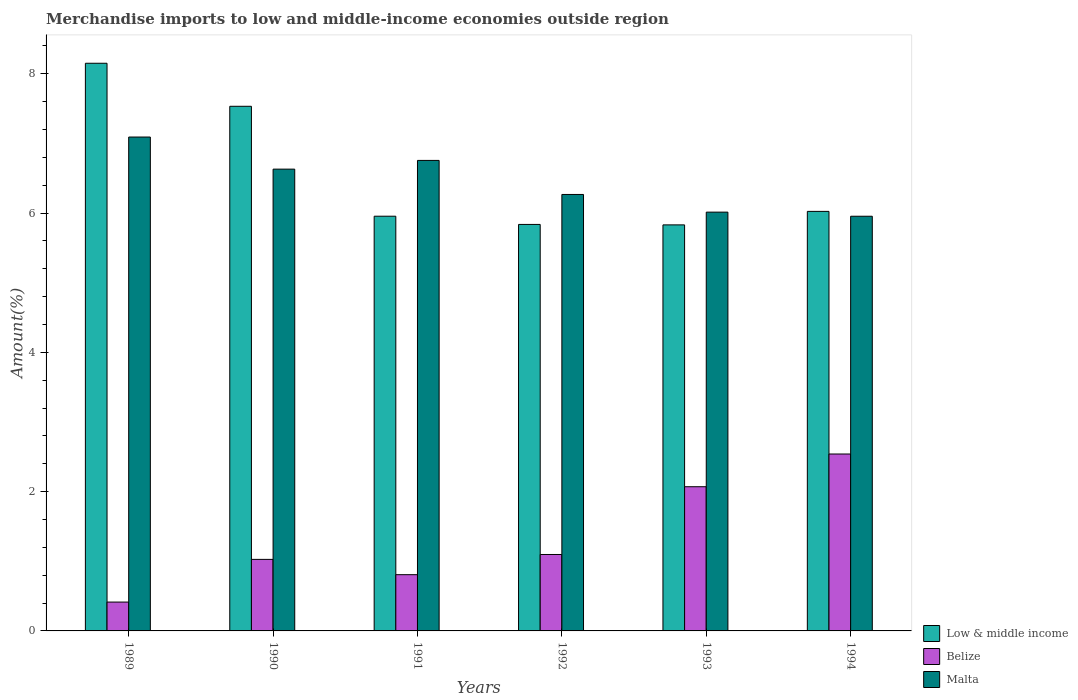How many different coloured bars are there?
Offer a terse response. 3. Are the number of bars per tick equal to the number of legend labels?
Make the answer very short. Yes. What is the label of the 3rd group of bars from the left?
Give a very brief answer. 1991. In how many cases, is the number of bars for a given year not equal to the number of legend labels?
Offer a very short reply. 0. What is the percentage of amount earned from merchandise imports in Belize in 1991?
Your answer should be very brief. 0.81. Across all years, what is the maximum percentage of amount earned from merchandise imports in Malta?
Make the answer very short. 7.09. Across all years, what is the minimum percentage of amount earned from merchandise imports in Malta?
Ensure brevity in your answer.  5.95. In which year was the percentage of amount earned from merchandise imports in Belize maximum?
Give a very brief answer. 1994. What is the total percentage of amount earned from merchandise imports in Belize in the graph?
Your answer should be very brief. 7.96. What is the difference between the percentage of amount earned from merchandise imports in Belize in 1990 and that in 1991?
Offer a terse response. 0.22. What is the difference between the percentage of amount earned from merchandise imports in Low & middle income in 1993 and the percentage of amount earned from merchandise imports in Malta in 1991?
Give a very brief answer. -0.93. What is the average percentage of amount earned from merchandise imports in Low & middle income per year?
Offer a terse response. 6.55. In the year 1994, what is the difference between the percentage of amount earned from merchandise imports in Low & middle income and percentage of amount earned from merchandise imports in Malta?
Offer a terse response. 0.07. In how many years, is the percentage of amount earned from merchandise imports in Belize greater than 4 %?
Provide a succinct answer. 0. What is the ratio of the percentage of amount earned from merchandise imports in Malta in 1989 to that in 1991?
Make the answer very short. 1.05. What is the difference between the highest and the second highest percentage of amount earned from merchandise imports in Low & middle income?
Keep it short and to the point. 0.62. What is the difference between the highest and the lowest percentage of amount earned from merchandise imports in Low & middle income?
Your answer should be compact. 2.32. In how many years, is the percentage of amount earned from merchandise imports in Belize greater than the average percentage of amount earned from merchandise imports in Belize taken over all years?
Ensure brevity in your answer.  2. What does the 2nd bar from the left in 1989 represents?
Your answer should be very brief. Belize. Is it the case that in every year, the sum of the percentage of amount earned from merchandise imports in Low & middle income and percentage of amount earned from merchandise imports in Malta is greater than the percentage of amount earned from merchandise imports in Belize?
Provide a succinct answer. Yes. Are all the bars in the graph horizontal?
Your answer should be compact. No. What is the difference between two consecutive major ticks on the Y-axis?
Provide a short and direct response. 2. Does the graph contain grids?
Ensure brevity in your answer.  No. Where does the legend appear in the graph?
Give a very brief answer. Bottom right. What is the title of the graph?
Your answer should be compact. Merchandise imports to low and middle-income economies outside region. What is the label or title of the X-axis?
Make the answer very short. Years. What is the label or title of the Y-axis?
Your response must be concise. Amount(%). What is the Amount(%) of Low & middle income in 1989?
Provide a succinct answer. 8.15. What is the Amount(%) in Belize in 1989?
Provide a short and direct response. 0.41. What is the Amount(%) of Malta in 1989?
Ensure brevity in your answer.  7.09. What is the Amount(%) in Low & middle income in 1990?
Provide a succinct answer. 7.53. What is the Amount(%) in Belize in 1990?
Give a very brief answer. 1.03. What is the Amount(%) of Malta in 1990?
Provide a short and direct response. 6.63. What is the Amount(%) in Low & middle income in 1991?
Keep it short and to the point. 5.95. What is the Amount(%) in Belize in 1991?
Make the answer very short. 0.81. What is the Amount(%) in Malta in 1991?
Provide a succinct answer. 6.76. What is the Amount(%) in Low & middle income in 1992?
Offer a terse response. 5.84. What is the Amount(%) in Belize in 1992?
Your answer should be very brief. 1.1. What is the Amount(%) of Malta in 1992?
Give a very brief answer. 6.27. What is the Amount(%) in Low & middle income in 1993?
Offer a terse response. 5.83. What is the Amount(%) in Belize in 1993?
Provide a short and direct response. 2.07. What is the Amount(%) of Malta in 1993?
Your response must be concise. 6.01. What is the Amount(%) in Low & middle income in 1994?
Keep it short and to the point. 6.02. What is the Amount(%) in Belize in 1994?
Provide a succinct answer. 2.54. What is the Amount(%) in Malta in 1994?
Your response must be concise. 5.95. Across all years, what is the maximum Amount(%) in Low & middle income?
Your answer should be very brief. 8.15. Across all years, what is the maximum Amount(%) in Belize?
Provide a short and direct response. 2.54. Across all years, what is the maximum Amount(%) of Malta?
Your response must be concise. 7.09. Across all years, what is the minimum Amount(%) in Low & middle income?
Offer a very short reply. 5.83. Across all years, what is the minimum Amount(%) of Belize?
Offer a very short reply. 0.41. Across all years, what is the minimum Amount(%) in Malta?
Make the answer very short. 5.95. What is the total Amount(%) in Low & middle income in the graph?
Provide a succinct answer. 39.33. What is the total Amount(%) in Belize in the graph?
Offer a very short reply. 7.96. What is the total Amount(%) of Malta in the graph?
Provide a short and direct response. 38.71. What is the difference between the Amount(%) in Low & middle income in 1989 and that in 1990?
Offer a terse response. 0.62. What is the difference between the Amount(%) of Belize in 1989 and that in 1990?
Your answer should be compact. -0.61. What is the difference between the Amount(%) in Malta in 1989 and that in 1990?
Offer a terse response. 0.46. What is the difference between the Amount(%) in Low & middle income in 1989 and that in 1991?
Provide a short and direct response. 2.2. What is the difference between the Amount(%) in Belize in 1989 and that in 1991?
Provide a succinct answer. -0.39. What is the difference between the Amount(%) of Malta in 1989 and that in 1991?
Keep it short and to the point. 0.34. What is the difference between the Amount(%) in Low & middle income in 1989 and that in 1992?
Ensure brevity in your answer.  2.31. What is the difference between the Amount(%) of Belize in 1989 and that in 1992?
Offer a very short reply. -0.68. What is the difference between the Amount(%) in Malta in 1989 and that in 1992?
Your answer should be very brief. 0.82. What is the difference between the Amount(%) of Low & middle income in 1989 and that in 1993?
Give a very brief answer. 2.32. What is the difference between the Amount(%) in Belize in 1989 and that in 1993?
Offer a terse response. -1.66. What is the difference between the Amount(%) in Malta in 1989 and that in 1993?
Your response must be concise. 1.08. What is the difference between the Amount(%) of Low & middle income in 1989 and that in 1994?
Make the answer very short. 2.13. What is the difference between the Amount(%) in Belize in 1989 and that in 1994?
Provide a succinct answer. -2.13. What is the difference between the Amount(%) in Malta in 1989 and that in 1994?
Your response must be concise. 1.14. What is the difference between the Amount(%) in Low & middle income in 1990 and that in 1991?
Your answer should be compact. 1.58. What is the difference between the Amount(%) in Belize in 1990 and that in 1991?
Give a very brief answer. 0.22. What is the difference between the Amount(%) in Malta in 1990 and that in 1991?
Keep it short and to the point. -0.12. What is the difference between the Amount(%) of Low & middle income in 1990 and that in 1992?
Your response must be concise. 1.7. What is the difference between the Amount(%) of Belize in 1990 and that in 1992?
Give a very brief answer. -0.07. What is the difference between the Amount(%) in Malta in 1990 and that in 1992?
Keep it short and to the point. 0.36. What is the difference between the Amount(%) in Low & middle income in 1990 and that in 1993?
Offer a terse response. 1.7. What is the difference between the Amount(%) in Belize in 1990 and that in 1993?
Keep it short and to the point. -1.04. What is the difference between the Amount(%) of Malta in 1990 and that in 1993?
Ensure brevity in your answer.  0.62. What is the difference between the Amount(%) of Low & middle income in 1990 and that in 1994?
Give a very brief answer. 1.51. What is the difference between the Amount(%) in Belize in 1990 and that in 1994?
Keep it short and to the point. -1.51. What is the difference between the Amount(%) in Malta in 1990 and that in 1994?
Your response must be concise. 0.68. What is the difference between the Amount(%) of Low & middle income in 1991 and that in 1992?
Keep it short and to the point. 0.12. What is the difference between the Amount(%) in Belize in 1991 and that in 1992?
Ensure brevity in your answer.  -0.29. What is the difference between the Amount(%) of Malta in 1991 and that in 1992?
Make the answer very short. 0.49. What is the difference between the Amount(%) in Low & middle income in 1991 and that in 1993?
Your answer should be compact. 0.12. What is the difference between the Amount(%) in Belize in 1991 and that in 1993?
Make the answer very short. -1.26. What is the difference between the Amount(%) of Malta in 1991 and that in 1993?
Provide a succinct answer. 0.74. What is the difference between the Amount(%) of Low & middle income in 1991 and that in 1994?
Offer a terse response. -0.07. What is the difference between the Amount(%) in Belize in 1991 and that in 1994?
Your response must be concise. -1.73. What is the difference between the Amount(%) of Malta in 1991 and that in 1994?
Offer a terse response. 0.8. What is the difference between the Amount(%) of Low & middle income in 1992 and that in 1993?
Your response must be concise. 0.01. What is the difference between the Amount(%) in Belize in 1992 and that in 1993?
Make the answer very short. -0.97. What is the difference between the Amount(%) of Malta in 1992 and that in 1993?
Your response must be concise. 0.25. What is the difference between the Amount(%) in Low & middle income in 1992 and that in 1994?
Provide a short and direct response. -0.19. What is the difference between the Amount(%) in Belize in 1992 and that in 1994?
Keep it short and to the point. -1.44. What is the difference between the Amount(%) of Malta in 1992 and that in 1994?
Provide a short and direct response. 0.31. What is the difference between the Amount(%) of Low & middle income in 1993 and that in 1994?
Your answer should be compact. -0.19. What is the difference between the Amount(%) in Belize in 1993 and that in 1994?
Provide a short and direct response. -0.47. What is the difference between the Amount(%) in Malta in 1993 and that in 1994?
Offer a terse response. 0.06. What is the difference between the Amount(%) of Low & middle income in 1989 and the Amount(%) of Belize in 1990?
Keep it short and to the point. 7.12. What is the difference between the Amount(%) of Low & middle income in 1989 and the Amount(%) of Malta in 1990?
Offer a very short reply. 1.52. What is the difference between the Amount(%) of Belize in 1989 and the Amount(%) of Malta in 1990?
Your answer should be very brief. -6.22. What is the difference between the Amount(%) of Low & middle income in 1989 and the Amount(%) of Belize in 1991?
Offer a very short reply. 7.34. What is the difference between the Amount(%) in Low & middle income in 1989 and the Amount(%) in Malta in 1991?
Provide a short and direct response. 1.39. What is the difference between the Amount(%) in Belize in 1989 and the Amount(%) in Malta in 1991?
Give a very brief answer. -6.34. What is the difference between the Amount(%) in Low & middle income in 1989 and the Amount(%) in Belize in 1992?
Provide a short and direct response. 7.05. What is the difference between the Amount(%) in Low & middle income in 1989 and the Amount(%) in Malta in 1992?
Your response must be concise. 1.88. What is the difference between the Amount(%) of Belize in 1989 and the Amount(%) of Malta in 1992?
Your answer should be very brief. -5.85. What is the difference between the Amount(%) of Low & middle income in 1989 and the Amount(%) of Belize in 1993?
Offer a very short reply. 6.08. What is the difference between the Amount(%) in Low & middle income in 1989 and the Amount(%) in Malta in 1993?
Give a very brief answer. 2.14. What is the difference between the Amount(%) of Belize in 1989 and the Amount(%) of Malta in 1993?
Keep it short and to the point. -5.6. What is the difference between the Amount(%) of Low & middle income in 1989 and the Amount(%) of Belize in 1994?
Give a very brief answer. 5.61. What is the difference between the Amount(%) in Low & middle income in 1989 and the Amount(%) in Malta in 1994?
Provide a short and direct response. 2.2. What is the difference between the Amount(%) in Belize in 1989 and the Amount(%) in Malta in 1994?
Offer a terse response. -5.54. What is the difference between the Amount(%) in Low & middle income in 1990 and the Amount(%) in Belize in 1991?
Your response must be concise. 6.72. What is the difference between the Amount(%) of Low & middle income in 1990 and the Amount(%) of Malta in 1991?
Make the answer very short. 0.78. What is the difference between the Amount(%) in Belize in 1990 and the Amount(%) in Malta in 1991?
Your answer should be very brief. -5.73. What is the difference between the Amount(%) of Low & middle income in 1990 and the Amount(%) of Belize in 1992?
Offer a very short reply. 6.43. What is the difference between the Amount(%) in Low & middle income in 1990 and the Amount(%) in Malta in 1992?
Your answer should be compact. 1.27. What is the difference between the Amount(%) in Belize in 1990 and the Amount(%) in Malta in 1992?
Ensure brevity in your answer.  -5.24. What is the difference between the Amount(%) in Low & middle income in 1990 and the Amount(%) in Belize in 1993?
Offer a very short reply. 5.46. What is the difference between the Amount(%) of Low & middle income in 1990 and the Amount(%) of Malta in 1993?
Give a very brief answer. 1.52. What is the difference between the Amount(%) in Belize in 1990 and the Amount(%) in Malta in 1993?
Provide a succinct answer. -4.99. What is the difference between the Amount(%) in Low & middle income in 1990 and the Amount(%) in Belize in 1994?
Provide a succinct answer. 4.99. What is the difference between the Amount(%) in Low & middle income in 1990 and the Amount(%) in Malta in 1994?
Your answer should be compact. 1.58. What is the difference between the Amount(%) of Belize in 1990 and the Amount(%) of Malta in 1994?
Provide a succinct answer. -4.93. What is the difference between the Amount(%) in Low & middle income in 1991 and the Amount(%) in Belize in 1992?
Ensure brevity in your answer.  4.86. What is the difference between the Amount(%) in Low & middle income in 1991 and the Amount(%) in Malta in 1992?
Provide a succinct answer. -0.31. What is the difference between the Amount(%) of Belize in 1991 and the Amount(%) of Malta in 1992?
Your response must be concise. -5.46. What is the difference between the Amount(%) of Low & middle income in 1991 and the Amount(%) of Belize in 1993?
Ensure brevity in your answer.  3.88. What is the difference between the Amount(%) in Low & middle income in 1991 and the Amount(%) in Malta in 1993?
Give a very brief answer. -0.06. What is the difference between the Amount(%) of Belize in 1991 and the Amount(%) of Malta in 1993?
Offer a very short reply. -5.21. What is the difference between the Amount(%) in Low & middle income in 1991 and the Amount(%) in Belize in 1994?
Your answer should be compact. 3.41. What is the difference between the Amount(%) of Low & middle income in 1991 and the Amount(%) of Malta in 1994?
Offer a terse response. 0. What is the difference between the Amount(%) of Belize in 1991 and the Amount(%) of Malta in 1994?
Offer a terse response. -5.15. What is the difference between the Amount(%) in Low & middle income in 1992 and the Amount(%) in Belize in 1993?
Make the answer very short. 3.77. What is the difference between the Amount(%) of Low & middle income in 1992 and the Amount(%) of Malta in 1993?
Provide a short and direct response. -0.18. What is the difference between the Amount(%) in Belize in 1992 and the Amount(%) in Malta in 1993?
Ensure brevity in your answer.  -4.92. What is the difference between the Amount(%) in Low & middle income in 1992 and the Amount(%) in Belize in 1994?
Offer a terse response. 3.3. What is the difference between the Amount(%) in Low & middle income in 1992 and the Amount(%) in Malta in 1994?
Offer a very short reply. -0.12. What is the difference between the Amount(%) in Belize in 1992 and the Amount(%) in Malta in 1994?
Your response must be concise. -4.86. What is the difference between the Amount(%) in Low & middle income in 1993 and the Amount(%) in Belize in 1994?
Offer a very short reply. 3.29. What is the difference between the Amount(%) in Low & middle income in 1993 and the Amount(%) in Malta in 1994?
Offer a terse response. -0.12. What is the difference between the Amount(%) in Belize in 1993 and the Amount(%) in Malta in 1994?
Make the answer very short. -3.88. What is the average Amount(%) of Low & middle income per year?
Provide a succinct answer. 6.55. What is the average Amount(%) in Belize per year?
Your answer should be very brief. 1.33. What is the average Amount(%) of Malta per year?
Offer a very short reply. 6.45. In the year 1989, what is the difference between the Amount(%) in Low & middle income and Amount(%) in Belize?
Your answer should be very brief. 7.74. In the year 1989, what is the difference between the Amount(%) in Low & middle income and Amount(%) in Malta?
Provide a short and direct response. 1.06. In the year 1989, what is the difference between the Amount(%) in Belize and Amount(%) in Malta?
Your answer should be compact. -6.68. In the year 1990, what is the difference between the Amount(%) in Low & middle income and Amount(%) in Belize?
Offer a very short reply. 6.51. In the year 1990, what is the difference between the Amount(%) of Low & middle income and Amount(%) of Malta?
Your response must be concise. 0.9. In the year 1990, what is the difference between the Amount(%) in Belize and Amount(%) in Malta?
Offer a terse response. -5.6. In the year 1991, what is the difference between the Amount(%) in Low & middle income and Amount(%) in Belize?
Give a very brief answer. 5.15. In the year 1991, what is the difference between the Amount(%) in Low & middle income and Amount(%) in Malta?
Your response must be concise. -0.8. In the year 1991, what is the difference between the Amount(%) in Belize and Amount(%) in Malta?
Your answer should be very brief. -5.95. In the year 1992, what is the difference between the Amount(%) in Low & middle income and Amount(%) in Belize?
Provide a short and direct response. 4.74. In the year 1992, what is the difference between the Amount(%) of Low & middle income and Amount(%) of Malta?
Your answer should be compact. -0.43. In the year 1992, what is the difference between the Amount(%) in Belize and Amount(%) in Malta?
Make the answer very short. -5.17. In the year 1993, what is the difference between the Amount(%) in Low & middle income and Amount(%) in Belize?
Offer a very short reply. 3.76. In the year 1993, what is the difference between the Amount(%) in Low & middle income and Amount(%) in Malta?
Provide a succinct answer. -0.18. In the year 1993, what is the difference between the Amount(%) in Belize and Amount(%) in Malta?
Ensure brevity in your answer.  -3.94. In the year 1994, what is the difference between the Amount(%) in Low & middle income and Amount(%) in Belize?
Your answer should be very brief. 3.48. In the year 1994, what is the difference between the Amount(%) in Low & middle income and Amount(%) in Malta?
Provide a succinct answer. 0.07. In the year 1994, what is the difference between the Amount(%) of Belize and Amount(%) of Malta?
Make the answer very short. -3.41. What is the ratio of the Amount(%) in Low & middle income in 1989 to that in 1990?
Provide a succinct answer. 1.08. What is the ratio of the Amount(%) of Belize in 1989 to that in 1990?
Your answer should be very brief. 0.4. What is the ratio of the Amount(%) in Malta in 1989 to that in 1990?
Your answer should be compact. 1.07. What is the ratio of the Amount(%) in Low & middle income in 1989 to that in 1991?
Offer a terse response. 1.37. What is the ratio of the Amount(%) of Belize in 1989 to that in 1991?
Your response must be concise. 0.51. What is the ratio of the Amount(%) in Malta in 1989 to that in 1991?
Your response must be concise. 1.05. What is the ratio of the Amount(%) of Low & middle income in 1989 to that in 1992?
Provide a short and direct response. 1.4. What is the ratio of the Amount(%) of Belize in 1989 to that in 1992?
Provide a succinct answer. 0.38. What is the ratio of the Amount(%) of Malta in 1989 to that in 1992?
Your answer should be very brief. 1.13. What is the ratio of the Amount(%) in Low & middle income in 1989 to that in 1993?
Your response must be concise. 1.4. What is the ratio of the Amount(%) in Belize in 1989 to that in 1993?
Offer a terse response. 0.2. What is the ratio of the Amount(%) of Malta in 1989 to that in 1993?
Provide a succinct answer. 1.18. What is the ratio of the Amount(%) of Low & middle income in 1989 to that in 1994?
Provide a short and direct response. 1.35. What is the ratio of the Amount(%) in Belize in 1989 to that in 1994?
Ensure brevity in your answer.  0.16. What is the ratio of the Amount(%) of Malta in 1989 to that in 1994?
Your answer should be very brief. 1.19. What is the ratio of the Amount(%) in Low & middle income in 1990 to that in 1991?
Keep it short and to the point. 1.27. What is the ratio of the Amount(%) in Belize in 1990 to that in 1991?
Your answer should be very brief. 1.27. What is the ratio of the Amount(%) of Malta in 1990 to that in 1991?
Make the answer very short. 0.98. What is the ratio of the Amount(%) of Low & middle income in 1990 to that in 1992?
Offer a terse response. 1.29. What is the ratio of the Amount(%) in Belize in 1990 to that in 1992?
Keep it short and to the point. 0.94. What is the ratio of the Amount(%) in Malta in 1990 to that in 1992?
Offer a very short reply. 1.06. What is the ratio of the Amount(%) in Low & middle income in 1990 to that in 1993?
Your answer should be very brief. 1.29. What is the ratio of the Amount(%) of Belize in 1990 to that in 1993?
Give a very brief answer. 0.5. What is the ratio of the Amount(%) in Malta in 1990 to that in 1993?
Your answer should be very brief. 1.1. What is the ratio of the Amount(%) in Low & middle income in 1990 to that in 1994?
Provide a short and direct response. 1.25. What is the ratio of the Amount(%) of Belize in 1990 to that in 1994?
Offer a very short reply. 0.4. What is the ratio of the Amount(%) of Malta in 1990 to that in 1994?
Keep it short and to the point. 1.11. What is the ratio of the Amount(%) in Low & middle income in 1991 to that in 1992?
Offer a terse response. 1.02. What is the ratio of the Amount(%) in Belize in 1991 to that in 1992?
Offer a terse response. 0.74. What is the ratio of the Amount(%) of Malta in 1991 to that in 1992?
Your answer should be very brief. 1.08. What is the ratio of the Amount(%) of Low & middle income in 1991 to that in 1993?
Your response must be concise. 1.02. What is the ratio of the Amount(%) in Belize in 1991 to that in 1993?
Ensure brevity in your answer.  0.39. What is the ratio of the Amount(%) of Malta in 1991 to that in 1993?
Offer a terse response. 1.12. What is the ratio of the Amount(%) of Belize in 1991 to that in 1994?
Keep it short and to the point. 0.32. What is the ratio of the Amount(%) in Malta in 1991 to that in 1994?
Your answer should be very brief. 1.13. What is the ratio of the Amount(%) in Low & middle income in 1992 to that in 1993?
Ensure brevity in your answer.  1. What is the ratio of the Amount(%) of Belize in 1992 to that in 1993?
Your response must be concise. 0.53. What is the ratio of the Amount(%) of Malta in 1992 to that in 1993?
Your answer should be very brief. 1.04. What is the ratio of the Amount(%) of Low & middle income in 1992 to that in 1994?
Make the answer very short. 0.97. What is the ratio of the Amount(%) in Belize in 1992 to that in 1994?
Give a very brief answer. 0.43. What is the ratio of the Amount(%) of Malta in 1992 to that in 1994?
Offer a terse response. 1.05. What is the ratio of the Amount(%) of Low & middle income in 1993 to that in 1994?
Your answer should be very brief. 0.97. What is the ratio of the Amount(%) in Belize in 1993 to that in 1994?
Offer a terse response. 0.82. What is the ratio of the Amount(%) of Malta in 1993 to that in 1994?
Your answer should be compact. 1.01. What is the difference between the highest and the second highest Amount(%) in Low & middle income?
Provide a short and direct response. 0.62. What is the difference between the highest and the second highest Amount(%) of Belize?
Your answer should be compact. 0.47. What is the difference between the highest and the second highest Amount(%) of Malta?
Offer a very short reply. 0.34. What is the difference between the highest and the lowest Amount(%) of Low & middle income?
Make the answer very short. 2.32. What is the difference between the highest and the lowest Amount(%) in Belize?
Keep it short and to the point. 2.13. What is the difference between the highest and the lowest Amount(%) in Malta?
Keep it short and to the point. 1.14. 